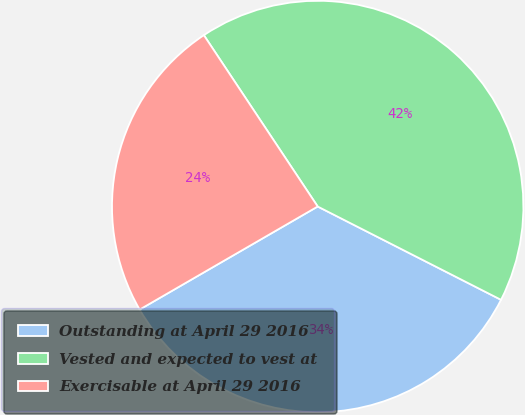Convert chart to OTSL. <chart><loc_0><loc_0><loc_500><loc_500><pie_chart><fcel>Outstanding at April 29 2016<fcel>Vested and expected to vest at<fcel>Exercisable at April 29 2016<nl><fcel>34.16%<fcel>41.83%<fcel>24.02%<nl></chart> 